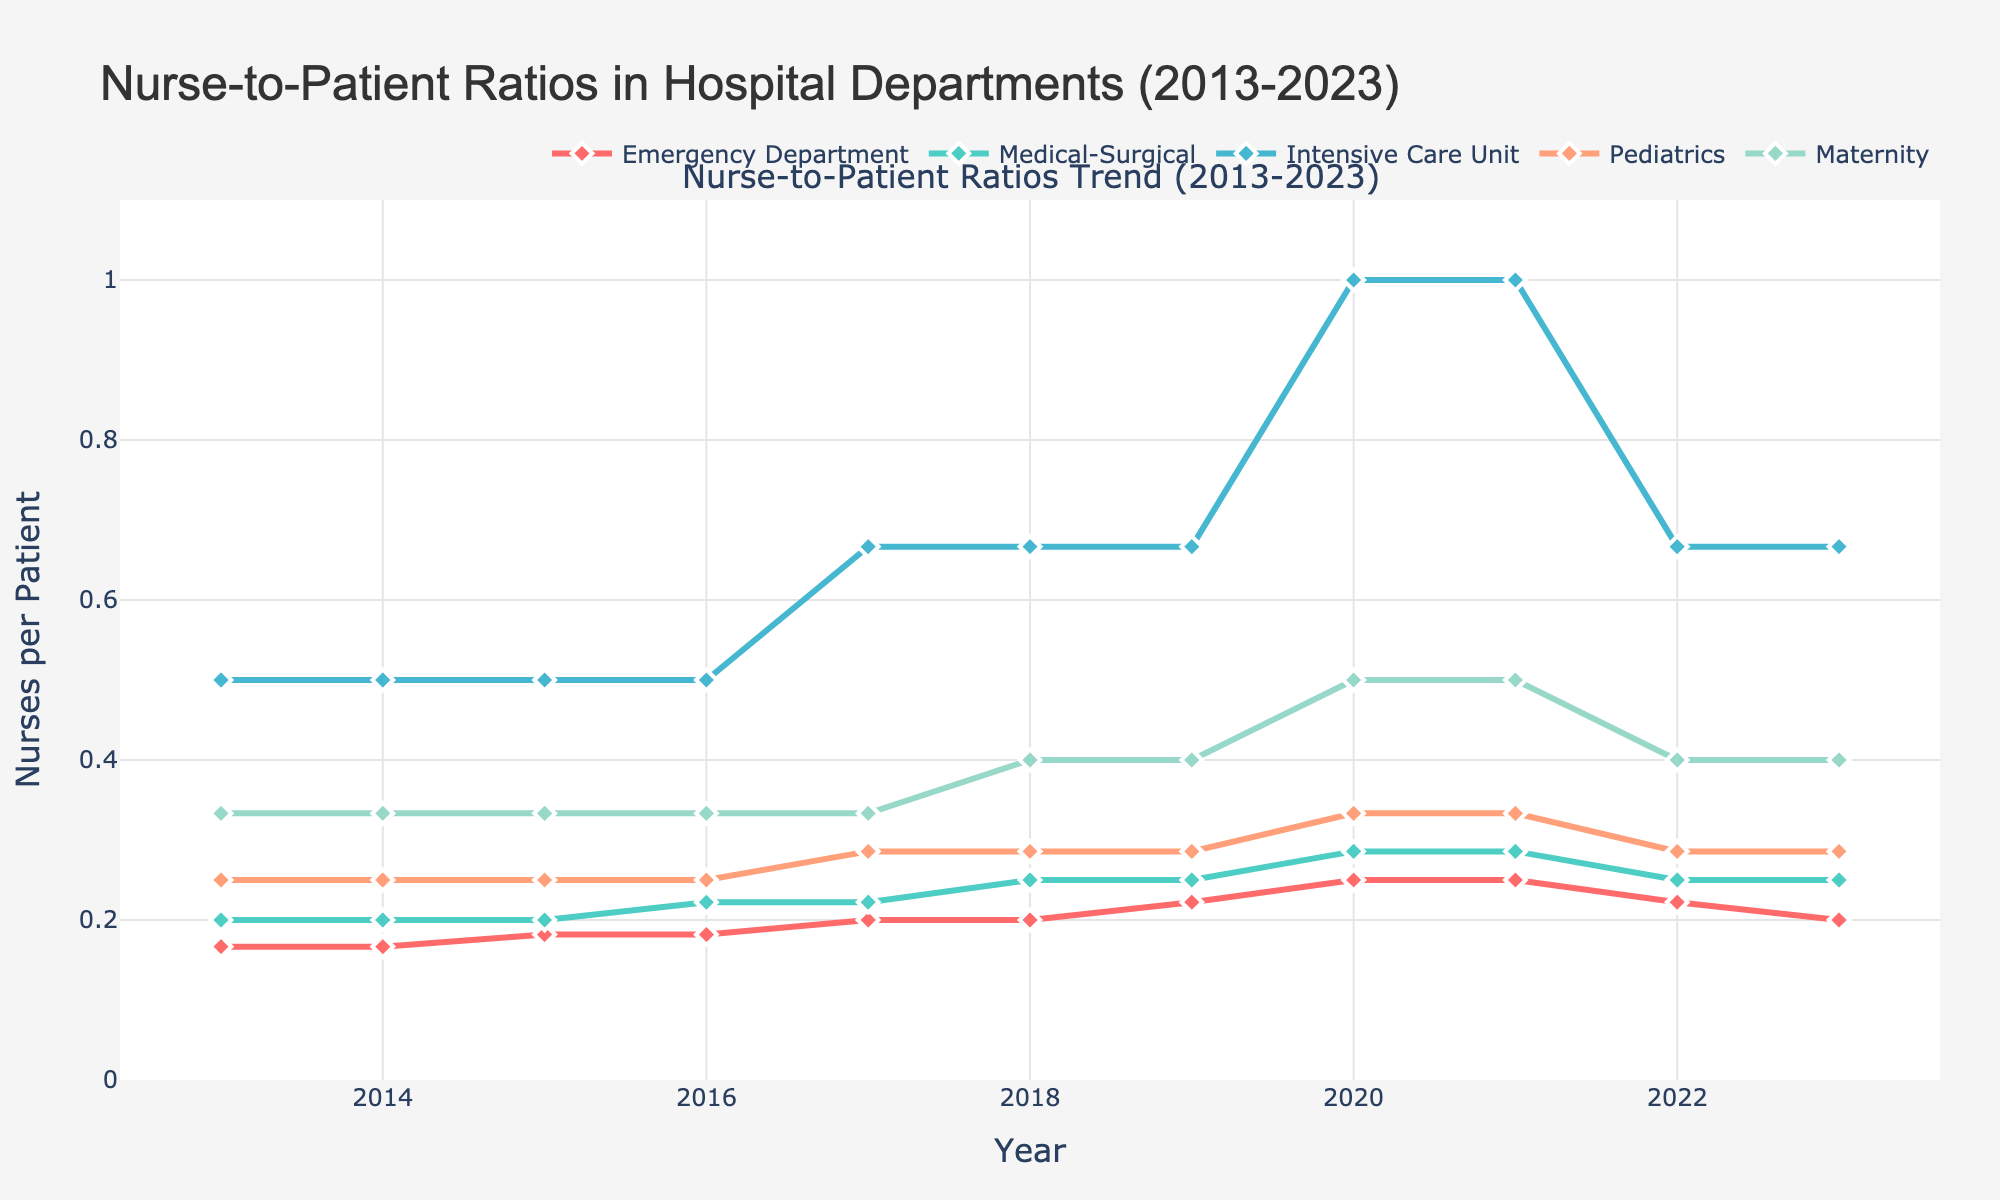What's the overall trend in the nurse-to-patient ratio in the Emergency Department over the past decade? The trend can be observed by tracking the changes in the line for the Emergency Department from 2013 to 2023. Initially, it starts at 1:6 in 2013, decreases gradually, reaching the lowest point of 1:4 in 2020 and 2021, before slightly increasing to 1:5 by 2023.
Answer: Decreasing overall Which department had the lowest nurse-to-patient ratio in 2020? This is observed by identifying which department's line has the highest value (lowest nurse-to-patient ratio) in 2020. The Intensive Care Unit had a ratio of 1:1.
Answer: Intensive Care Unit What was the average nurse-to-patient ratio for Pediatrics over the past decade? Sum the ratios for each year, convert them to numerical values, calculate the average. Numerically the values are: 1/4, 1/4, 1/4, 1/4, 1/3.5, 1/3.5, 1/3.5, 1/3, 1/3, 1/3.5, 1/3.5. Sum: 11.71, Average: 11.71/11 = 0.424. The average ratio is 1:2.358
Answer: 1:2.358 Between 2017 and 2019, how did the nurse-to-patient ratio change for the Medical-Surgical department? Compare the ratios in 2017 (1:4.5), 2018 (1:4), 2019 (1:4). The ratio improves (decreases) from 1:4.5 in 2017 to 1:4 in 2018 and remains constant in 2019.
Answer: Decreased and remained constant Which department showed the most significant improvement in nurse-to-patient ratios from 2013 to 2023? Improvement is indicated by the highest change in ratios. Calculate the difference from 2013 to 2023 for each. Intensive Care Unit improved from 1:2 to 1:1.5, which is the highest improvement observed.
Answer: Intensive Care Unit In which year did the Maternity department have its best (lowest) nurse-to-patient ratio, and what was the ratio? By tracking the Maternity line, the lowest point is in 2020 with a ratio of 1:2.
Answer: 2020, 1:2 How did the nurse-to-patient ratio in the Intensive Care Unit change from 2016 to 2017? By comparing the values from 2016 (1:2) to 2017 (1:1.5), the ratio improved (decreased).
Answer: Improved from 1:2 to 1:1.5 In which year did the Medical-Surgical department first see a decrease in the nurse-to-patient ratio? This can be observed by finding the first decrease from the initial ratio of 1:5. The first decrease happened in 2016 with a ratio of 1:4.5.
Answer: 2016 Compare the overall trend between Maternity and Pediatrics departments from 2013 to 2023. By observing both lines, Maternity shows a clear improvement (decrease from 1:3 to 1:2.5), while Pediatrics shows minor fluctuations around 1:4 to 1:3.5 without significant overall change.
Answer: Maternity improved, Pediatrics remained relatively stable What was the ratio difference between Emergency Department and Pediatrics in 2023? The Emergency Department had a ratio of 1:5 and Pediatrics had 1:3.5, the difference in numerical value can be calculated by (1/5) - (1/3.5).
Answer: Difference of roughly 0.057 